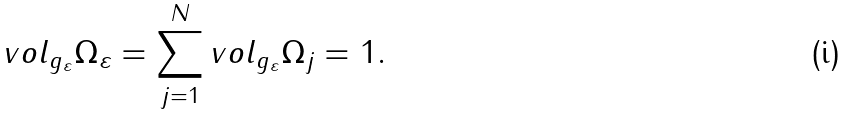Convert formula to latex. <formula><loc_0><loc_0><loc_500><loc_500>v o l _ { g _ { \varepsilon } } \Omega _ { \varepsilon } = \sum _ { j = 1 } ^ { N } v o l _ { g _ { \varepsilon } } \Omega _ { j } = 1 .</formula> 